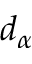Convert formula to latex. <formula><loc_0><loc_0><loc_500><loc_500>d _ { \alpha }</formula> 